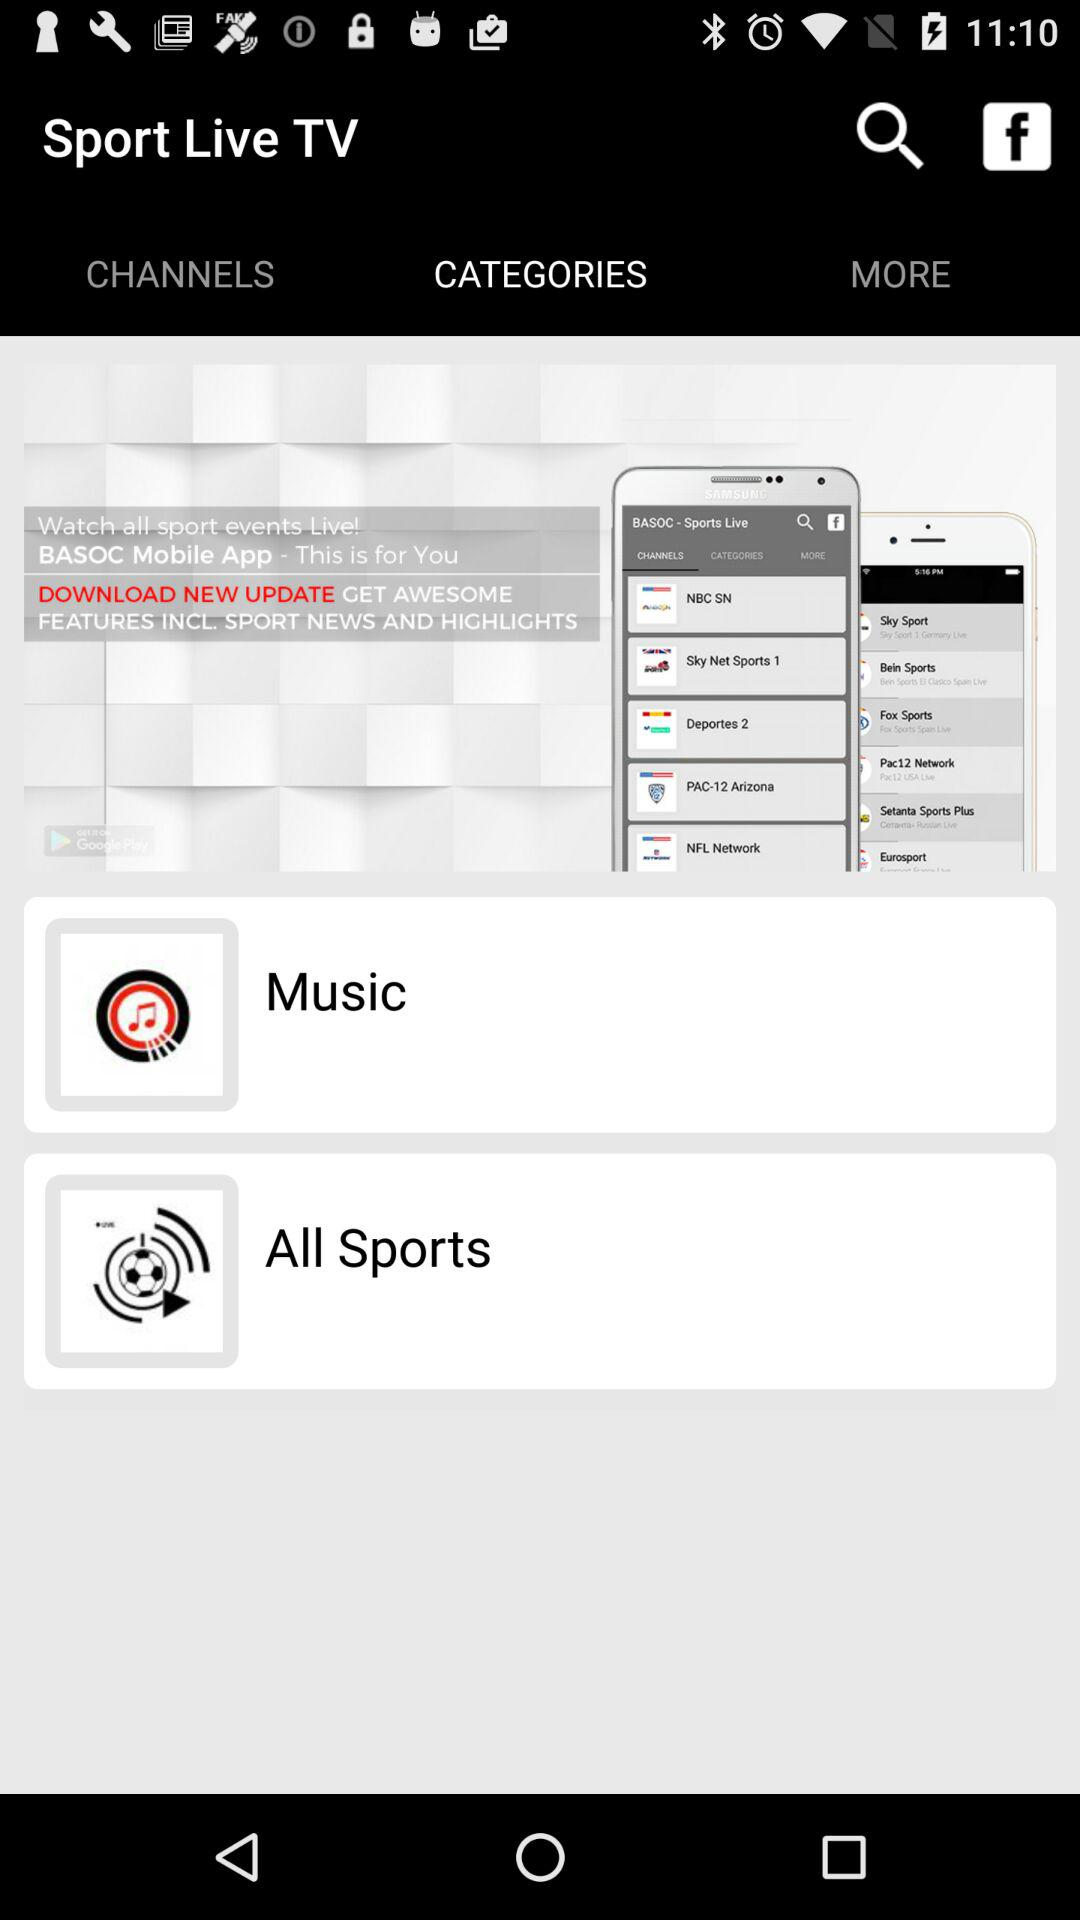What is the time?
When the provided information is insufficient, respond with <no answer>. <no answer> 